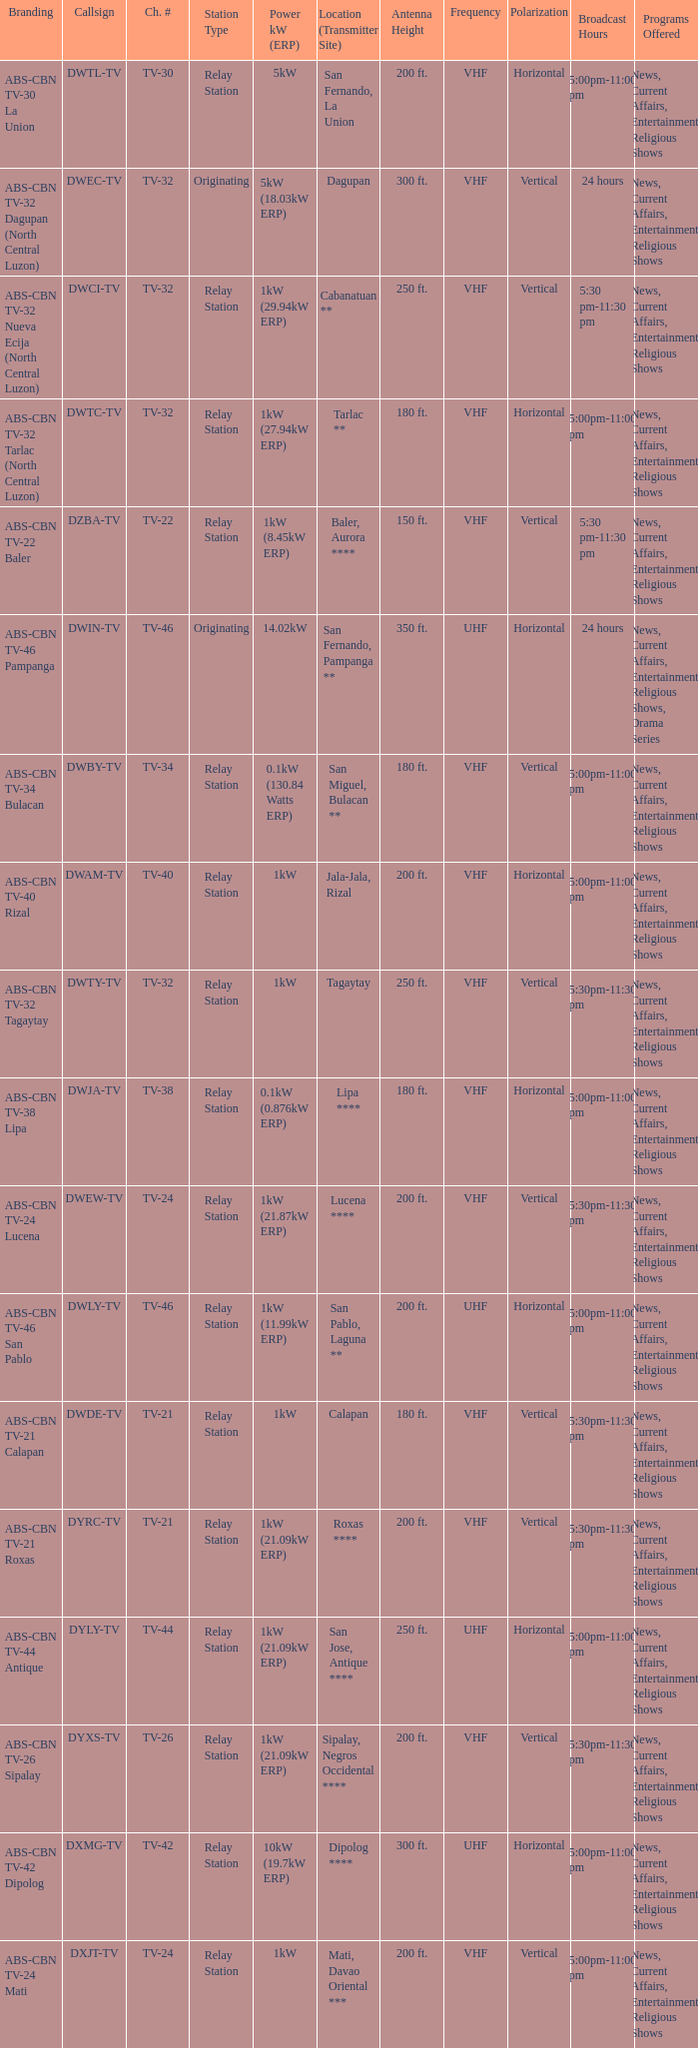The callsign DWEC-TV has what branding?  ABS-CBN TV-32 Dagupan (North Central Luzon). 